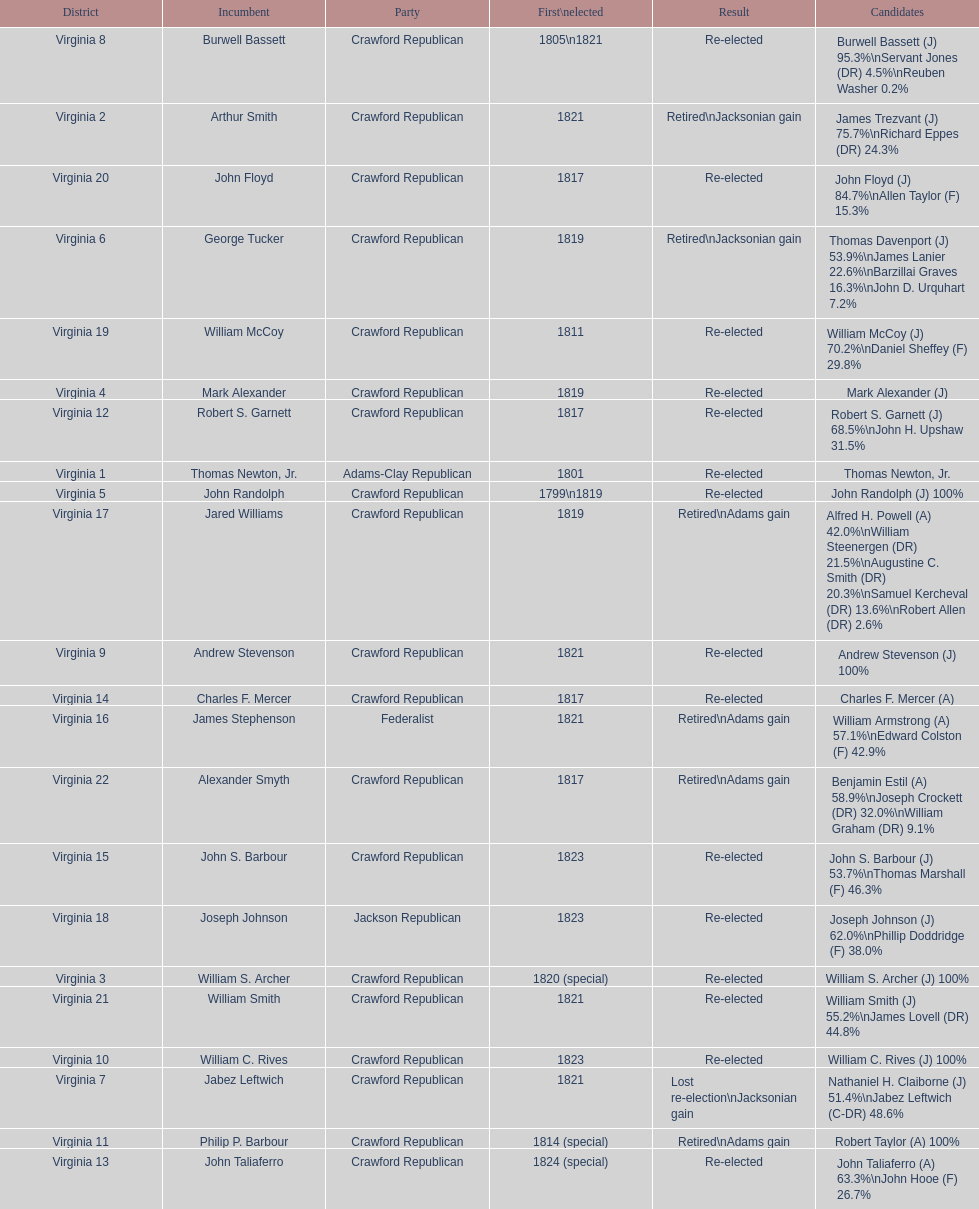Number of incumbents who retired or lost re-election 7. 